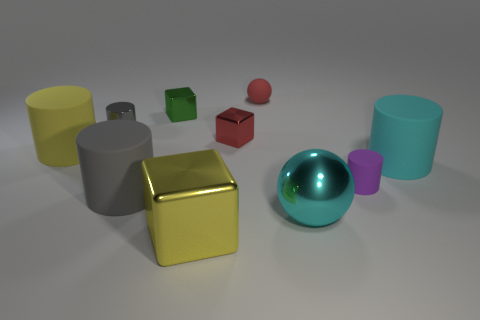What number of other objects are the same material as the tiny red ball?
Offer a very short reply. 4. Does the gray metal cylinder that is left of the matte ball have the same size as the ball that is behind the yellow cylinder?
Make the answer very short. Yes. How many objects are either metal things that are right of the tiny red metallic thing or rubber objects on the right side of the yellow matte object?
Your answer should be very brief. 5. Are there any other things that have the same shape as the tiny purple object?
Your answer should be very brief. Yes. Do the ball behind the yellow matte cylinder and the tiny metal thing that is right of the big yellow cube have the same color?
Your answer should be very brief. Yes. How many rubber things are either small purple cylinders or small objects?
Give a very brief answer. 2. Is there anything else that has the same size as the yellow cylinder?
Provide a succinct answer. Yes. What shape is the large yellow thing on the left side of the cube in front of the shiny sphere?
Make the answer very short. Cylinder. Are the cyan object behind the cyan shiny object and the tiny cylinder that is right of the small matte ball made of the same material?
Your answer should be very brief. Yes. What number of things are in front of the red thing that is behind the metallic cylinder?
Your answer should be compact. 9. 